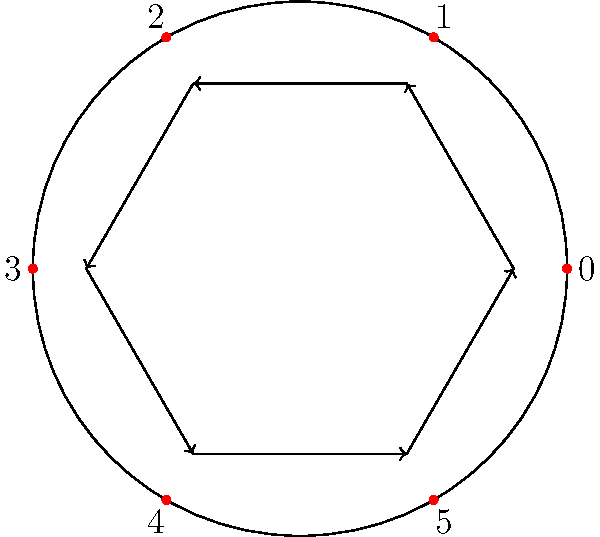In an animated GIF sequence representing a cyclic group of order 6, each frame shows a rotation of the elements. If the generator of this group is 1, how many frames are needed to return to the initial state, and what does this number represent in group theory terms? Let's approach this step-by-step:

1) The given diagram represents a cyclic group of order 6, with elements {0, 1, 2, 3, 4, 5}.

2) The generator of the group is given as 1. This means that repeated application of 1 generates all elements of the group.

3) Let's see how the generator acts on the elements:
   - 0 + 1 = 1
   - 1 + 1 = 2
   - 2 + 1 = 3
   - 3 + 1 = 4
   - 4 + 1 = 5
   - 5 + 1 = 0 (wrapping around in modulo 6)

4) We see that it takes 6 applications of the generator to return to the initial state (0).

5) In an animated GIF, each application of the generator would correspond to one frame, rotating the elements clockwise by one position.

6) Therefore, it would take 6 frames to return to the initial state.

7) In group theory terms, this number (6) represents the order of the group, which is also equal to the order of the generator in a cyclic group.

8) The order of an element in a group is the smallest positive integer $n$ such that $a^n = e$, where $a$ is the element and $e$ is the identity element of the group.

9) In this case, $1^6 = 0$ (in modulo 6 arithmetic), confirming that the order of the generator (and the group) is 6.
Answer: 6 frames; order of the group 